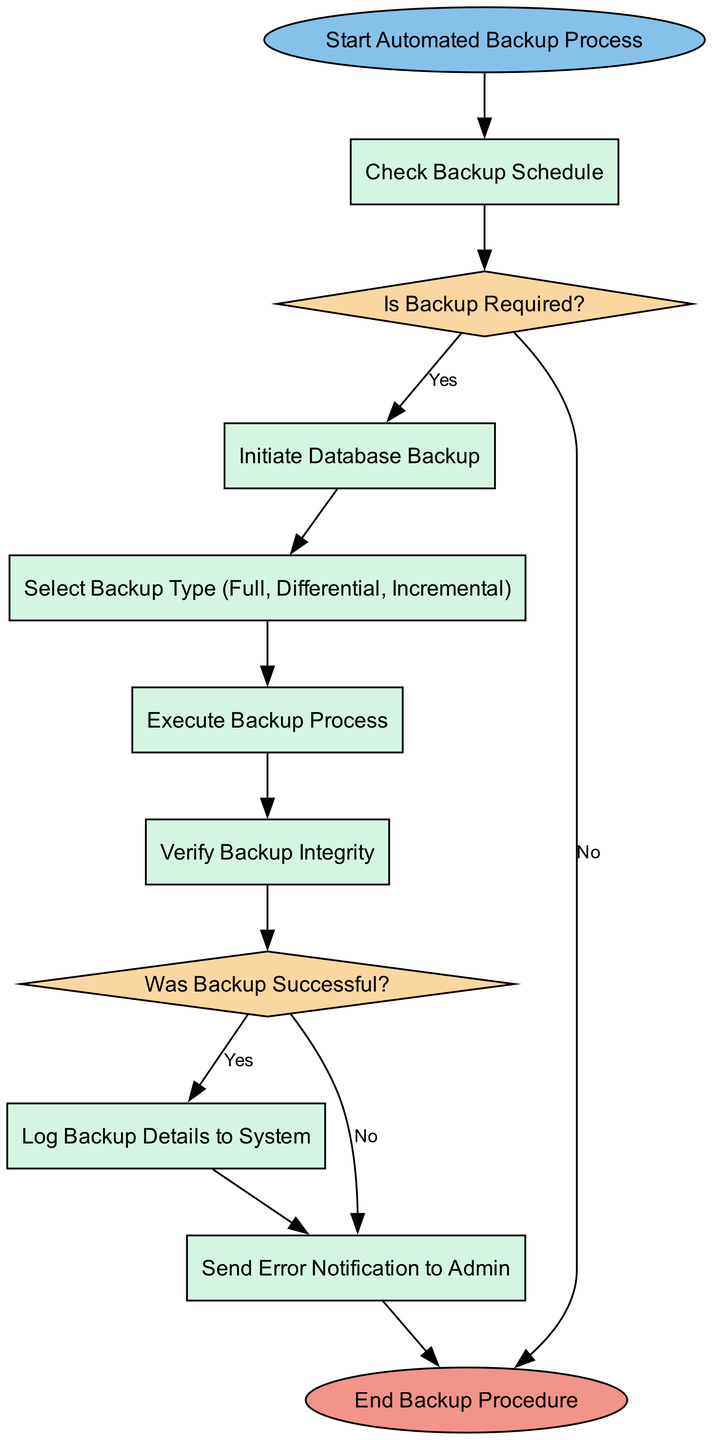What is the first step in the automated backup process? The diagram indicates that the first step in the process is labeled "Start Automated Backup Process."
Answer: Start Automated Backup Process How many decision nodes are present in the flow chart? By examining the diagram, there are two decision nodes: "Is Backup Required?" and "Was Backup Successful?"
Answer: 2 What happens if the backup is not required? The flowchart states that if the answer is "No" to the decision "Is Backup Required?", it leads to the process labeled "End Backup Procedure."
Answer: End Backup Procedure What follows after selecting the backup type? The diagram shows that after the node "Select Backup Type (Full, Differential, Incremental)," the next step is "Execute Backup Process."
Answer: Execute Backup Process What action is taken if the backup is unsuccessful? According to the diagram, if the response to the decision "Was Backup Successful?" is "No," it directs to the process labeled "Send Error Notification to Admin."
Answer: Send Error Notification to Admin What is the last action in the automated backup procedure? The flow diagram indicates that the last action is represented by the node labeled "End Backup Procedure."
Answer: End Backup Procedure Which process involves verifying the backup integrity? The node "Verify Backup Integrity" is specifically dedicated to that function as illustrated in the flow.
Answer: Verify Backup Integrity What action occurs after verifying the backup? Following "Verify Backup Integrity," the next step in the flow is the decision "Was Backup Successful?"
Answer: Was Backup Successful? What should be logged if the backup is successful? The flow indicates that the action "Log Backup Details to System" should occur if the backup is successful.
Answer: Log Backup Details to System 